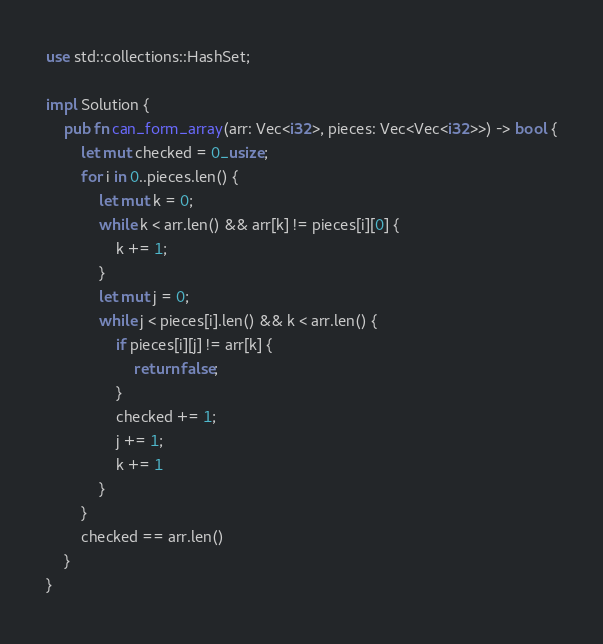<code> <loc_0><loc_0><loc_500><loc_500><_Rust_>use std::collections::HashSet;

impl Solution {
    pub fn can_form_array(arr: Vec<i32>, pieces: Vec<Vec<i32>>) -> bool {
        let mut checked = 0_usize;
        for i in 0..pieces.len() {
            let mut k = 0;
            while k < arr.len() && arr[k] != pieces[i][0] {
                k += 1;
            }
            let mut j = 0;
            while j < pieces[i].len() && k < arr.len() {
                if pieces[i][j] != arr[k] {
                    return false;
                }
                checked += 1;
                j += 1;
                k += 1
            }
        }
        checked == arr.len()
    }
}
</code> 